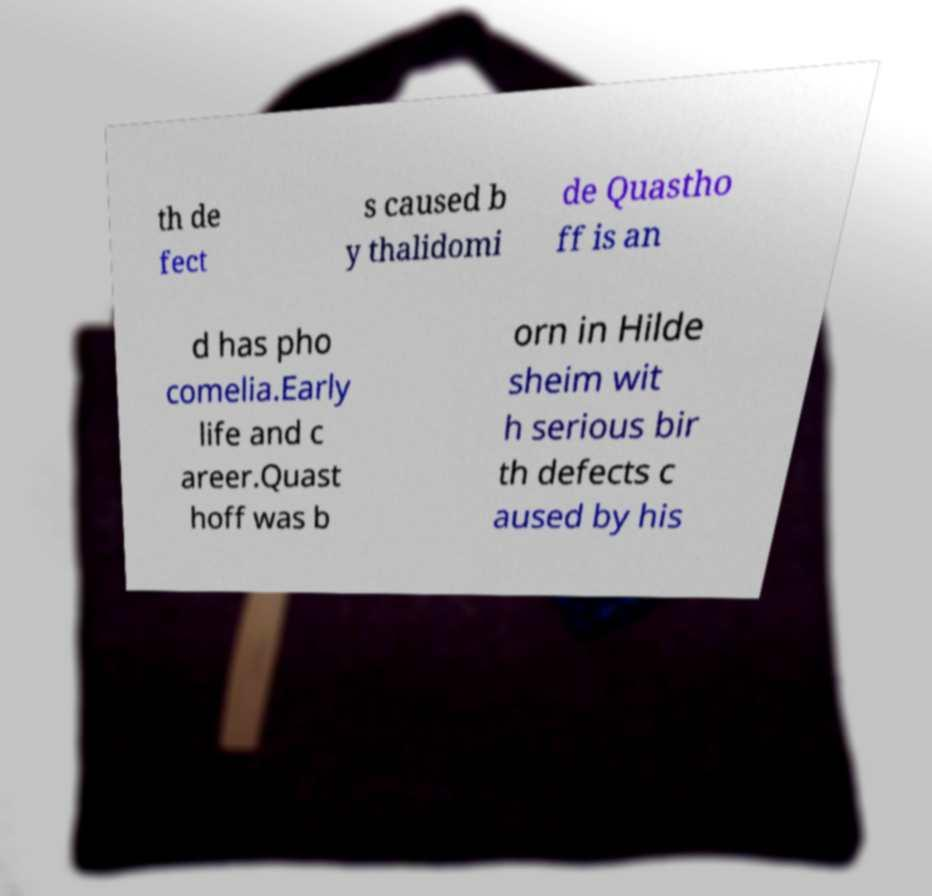Please read and relay the text visible in this image. What does it say? th de fect s caused b y thalidomi de Quastho ff is an d has pho comelia.Early life and c areer.Quast hoff was b orn in Hilde sheim wit h serious bir th defects c aused by his 